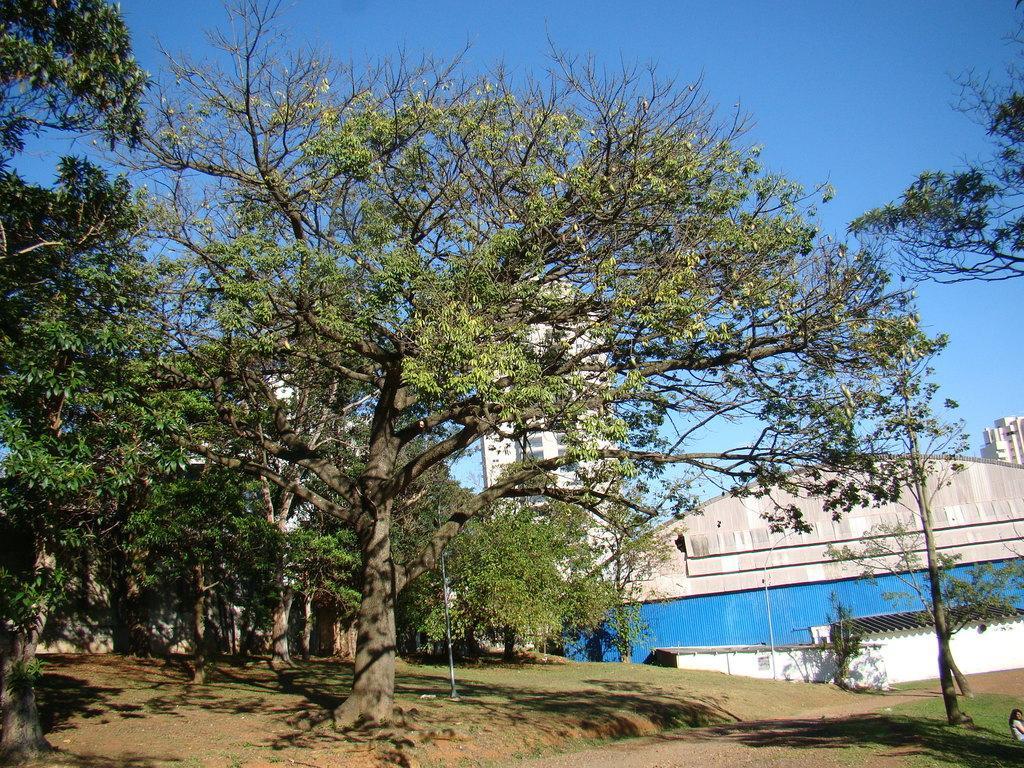Could you give a brief overview of what you see in this image? This image is taken outdoors. At the bottom of the image there is a ground with grass on it. On the left side of the image there are many trees. On the right side of the image there are a few buildings and a house with a few walls, windows, doors and roofs and there are a few trees. 